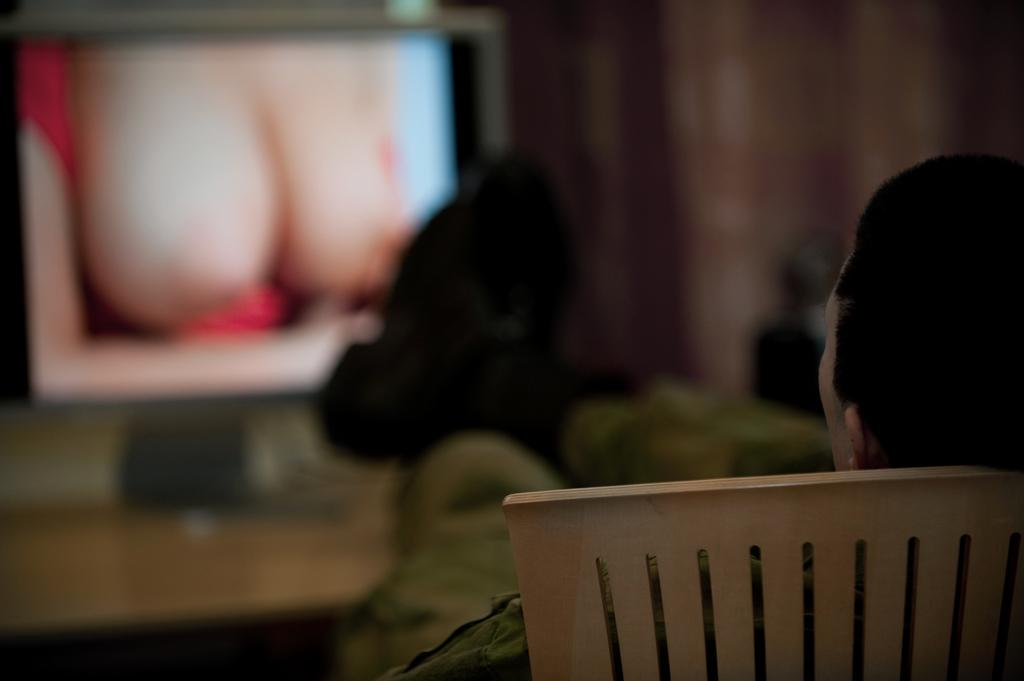What is the main subject of the image? A: There is a person seated on the chair on the right side of the image. Can you describe the background of the image? The background of the image is blurry. What type of system can be seen in the image? There is no system present in the image; it features a person seated on a chair in a blurry background. 